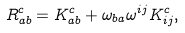<formula> <loc_0><loc_0><loc_500><loc_500>R ^ { c } _ { a b } = K ^ { c } _ { a b } + { \omega } _ { b a } { \omega } ^ { i j } K ^ { c } _ { i j } ,</formula> 